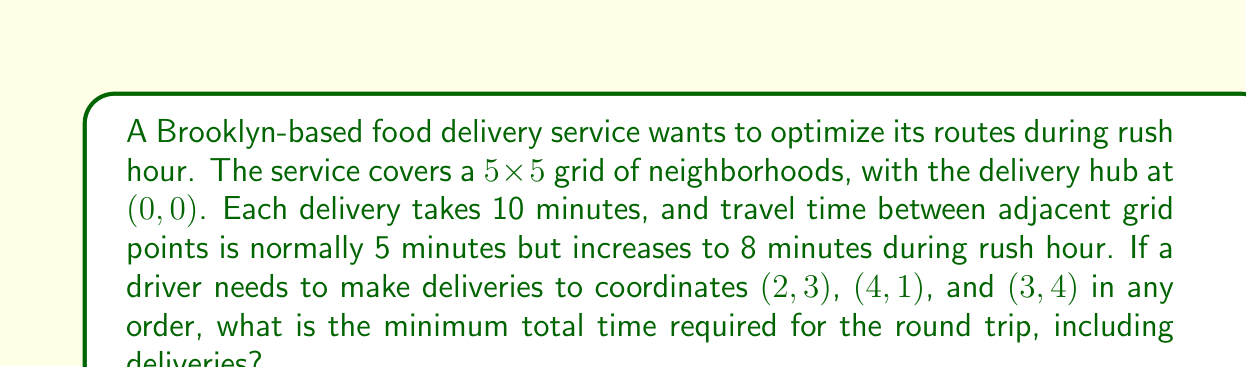Provide a solution to this math problem. Let's approach this step-by-step:

1) First, we need to calculate the distances between all points, including the hub (0,0). During rush hour, each grid movement takes 8 minutes.

   Hub to (2,3): $$(|2-0| + |3-0|) \cdot 8 = 40$$ minutes
   Hub to (4,1): $$(|4-0| + |1-0|) \cdot 8 = 40$$ minutes
   Hub to (3,4): $$(|3-0| + |4-0|) \cdot 8 = 56$$ minutes
   (2,3) to (4,1): $$(|4-2| + |1-3|) \cdot 8 = 32$$ minutes
   (2,3) to (3,4): $$(|3-2| + |4-3|) \cdot 8 = 16$$ minutes
   (4,1) to (3,4): $$(|3-4| + |4-1|) \cdot 8 = 32$$ minutes

2) Now, we need to find the shortest path that visits all points and returns to the hub. This is a Traveling Salesman Problem. For only 3 delivery points, we can check all possible routes:

   Route 1: Hub -> (2,3) -> (4,1) -> (3,4) -> Hub
   Time = 40 + 10 + 32 + 10 + 32 + 10 + 56 = 190 minutes

   Route 2: Hub -> (2,3) -> (3,4) -> (4,1) -> Hub
   Time = 40 + 10 + 16 + 10 + 32 + 10 + 40 = 158 minutes

   Route 3: Hub -> (4,1) -> (2,3) -> (3,4) -> Hub
   Time = 40 + 10 + 32 + 10 + 16 + 10 + 56 = 174 minutes

   Route 4: Hub -> (4,1) -> (3,4) -> (2,3) -> Hub
   Time = 40 + 10 + 32 + 10 + 16 + 10 + 40 = 158 minutes

   Route 5: Hub -> (3,4) -> (2,3) -> (4,1) -> Hub
   Time = 56 + 10 + 16 + 10 + 32 + 10 + 40 = 174 minutes

   Route 6: Hub -> (3,4) -> (4,1) -> (2,3) -> Hub
   Time = 56 + 10 + 32 + 10 + 32 + 10 + 40 = 190 minutes

3) The minimum time is 158 minutes, achieved by two routes: 
   Hub -> (2,3) -> (3,4) -> (4,1) -> Hub
   Hub -> (4,1) -> (3,4) -> (2,3) -> Hub
Answer: 158 minutes 